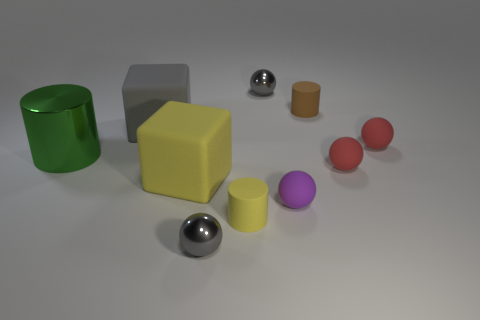Can you tell me what the largest object is and what color it is in this image? The largest object in the image is the gray cube. Its substantial size dominates over the other shapes and colors present. 